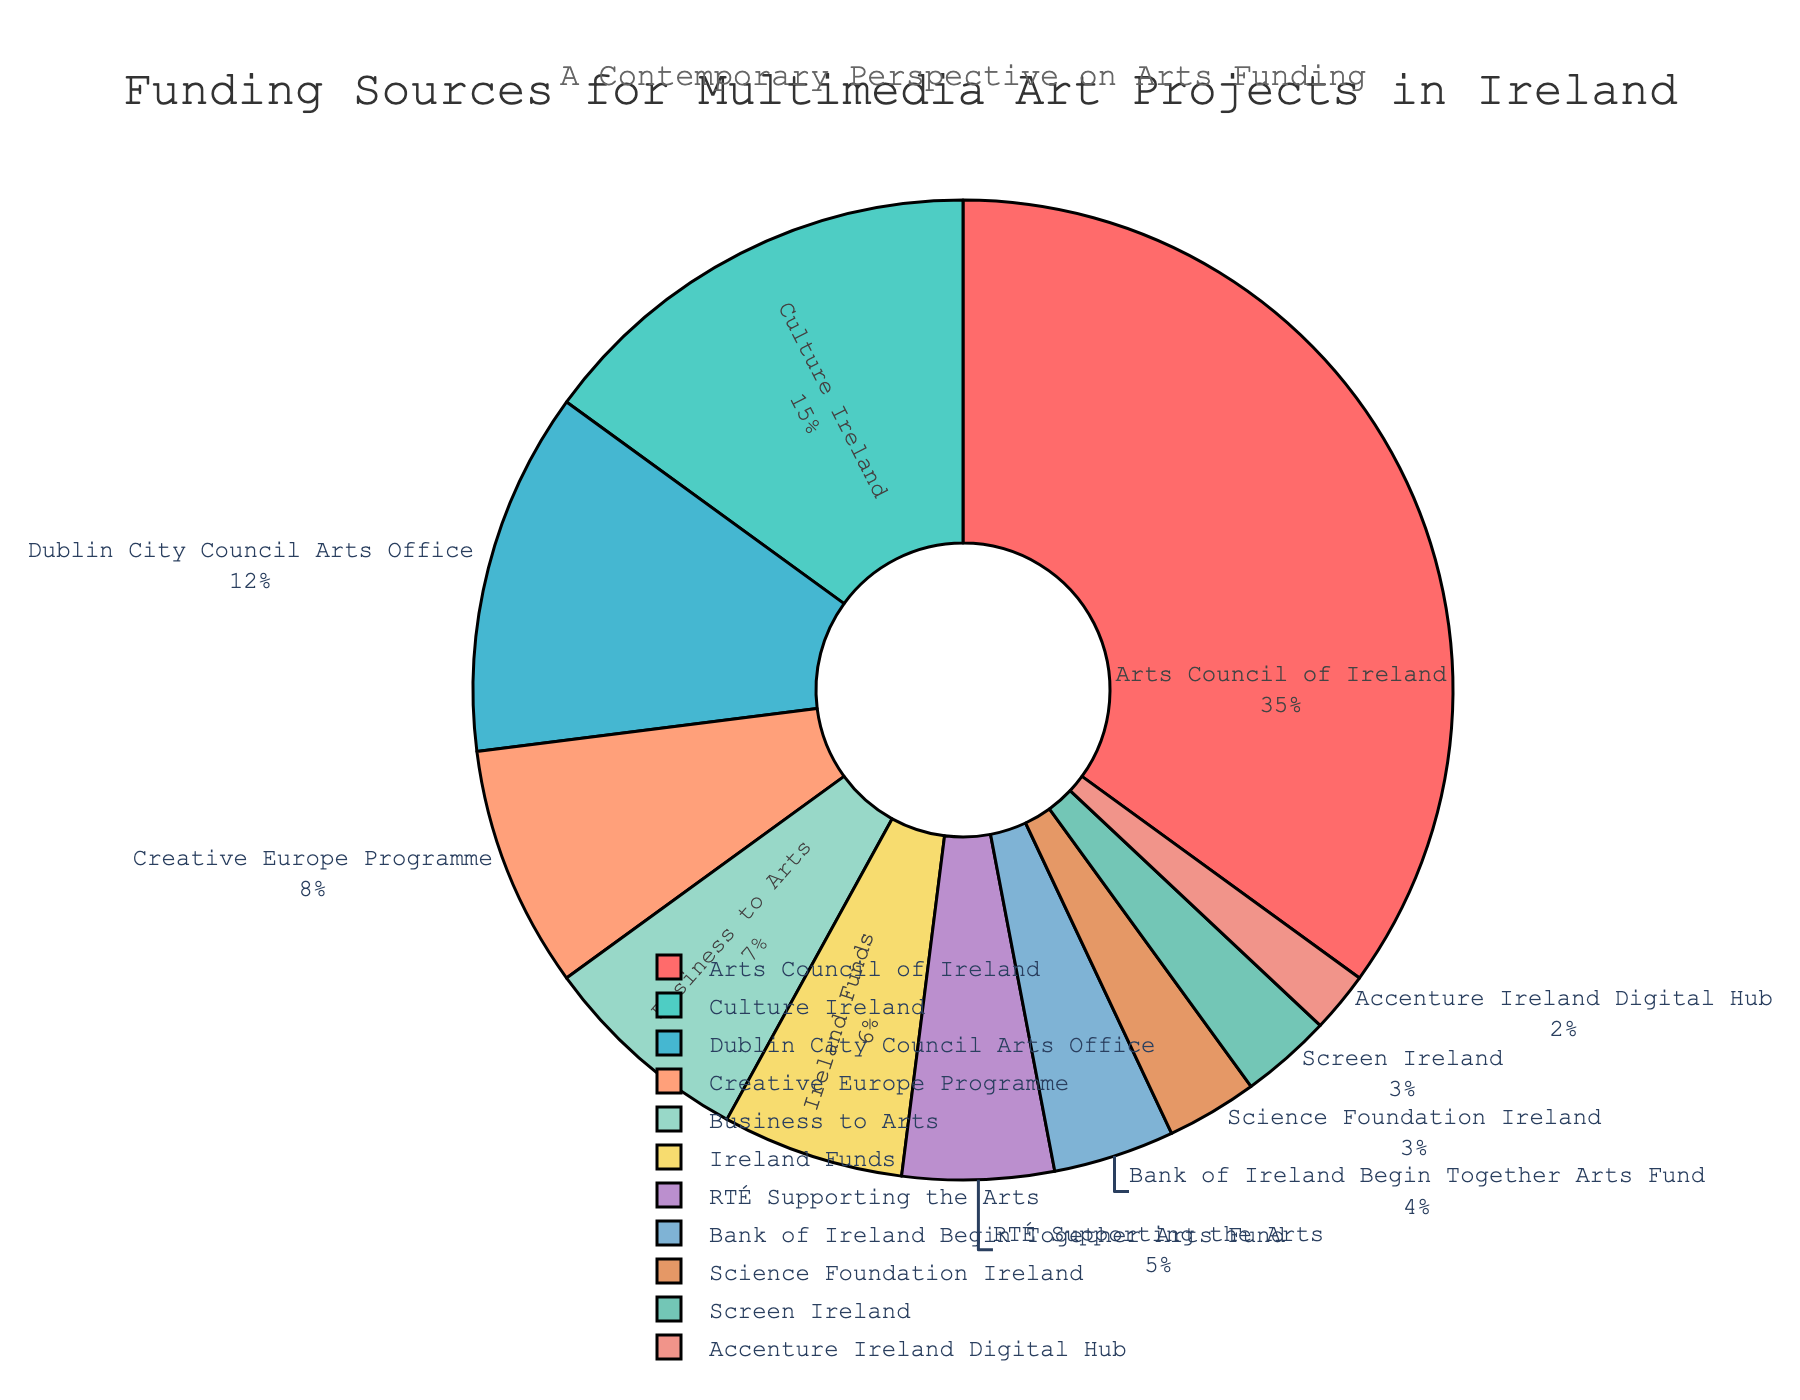What's the percentage of funding provided by the Arts Council of Ireland? The percentage is directly labeled on the pie chart for Arts Council of Ireland.
Answer: 35% Which funding source contributes less, Science Foundation Ireland or RTÉ Supporting the Arts? Look at the percentages for both sources on the pie chart. Science Foundation Ireland contributes 3%, while RTÉ Supporting the Arts contributes 5%.
Answer: Science Foundation Ireland What is the combined percentage of funding from Dublin City Council Arts Office and the Creative Europe Programme? Summing up the individual percentages: Dublin City Council Arts Office (12%) + Creative Europe Programme (8%) = 20%.
Answer: 20% How much more funding does the Culture Ireland provide compared to Business to Arts? Subtract the percentage of Business to Arts (7%) from the percentage of Culture Ireland (15%). 15% - 7% = 8%.
Answer: 8% What is the visual effect of the Arts Council of Ireland's segment in the pie chart? The segment for Arts Council of Ireland is the largest and is highlighted with a prominent color, making it visually stand out more than others.
Answer: It is the largest and most prominent Which funding source has a similar level of contribution as Business to Arts? Look for segments with percentages close to that of Business to Arts (7%). Ireland Funds contributes 6%, which is very close.
Answer: Ireland Funds Out of the given funding sources, which three have the smallest contributions? Look for the segments with the smallest percentages: Accenture Ireland Digital Hub (2%), Screen Ireland (3%), and Science Foundation Ireland (3%).
Answer: Accenture Ireland Digital Hub, Screen Ireland, Science Foundation Ireland If funding from the Arts Council of Ireland and Culture Ireland are combined, what is their total percentage? Summing up their individual percentages: Arts Council of Ireland (35%) + Culture Ireland (15%) = 50%.
Answer: 50% What is the percentage difference between funding from RTÉ Supporting the Arts and Bank of Ireland Begin Together Arts Fund? Subtract the percentage of the Bank of Ireland Begin Together Arts Fund (4%) from the percentage of RTÉ Supporting the Arts (5%): 5% - 4%.
Answer: 1% How does the color scheme help in differentiating the funding sources? The pie chart uses different colors for each source, making it easy to visually distinguish between segments based on their respective colors.
Answer: Uses different colors for each source 